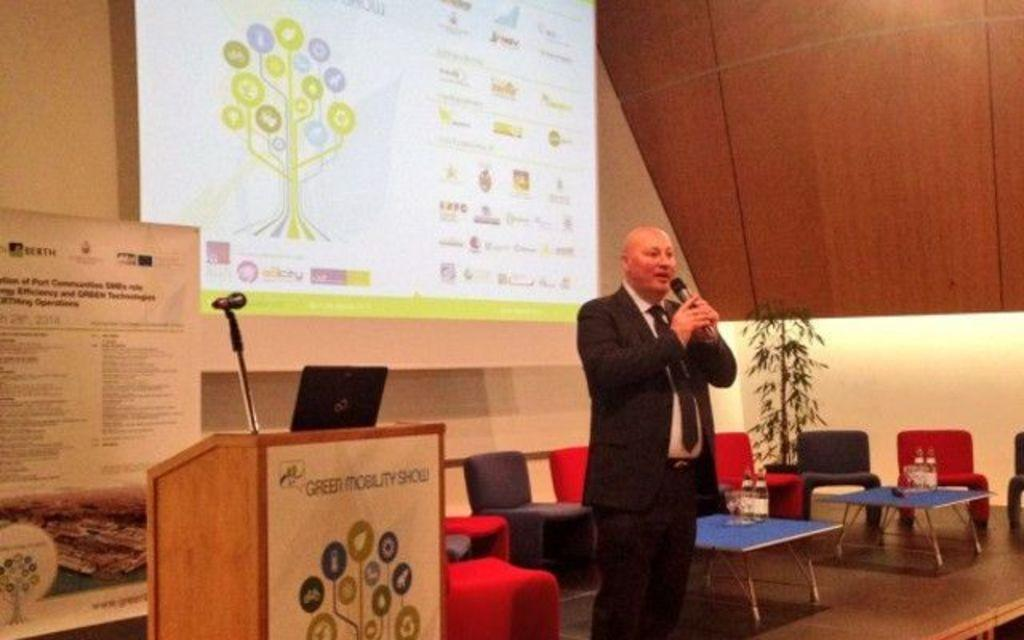What is the person in the image wearing? The person in the image is wearing a suit. What is the person doing in the image? The person is standing and speaking in front of a microphone. What type of furniture is present in the image? There are chairs and tables in the image. What can be seen in the background of the image? There is a projected image visible in the background. Where is the sink located in the image? There is no sink present in the image. What type of quartz can be seen on the table in the image? There is no quartz present in the image. 